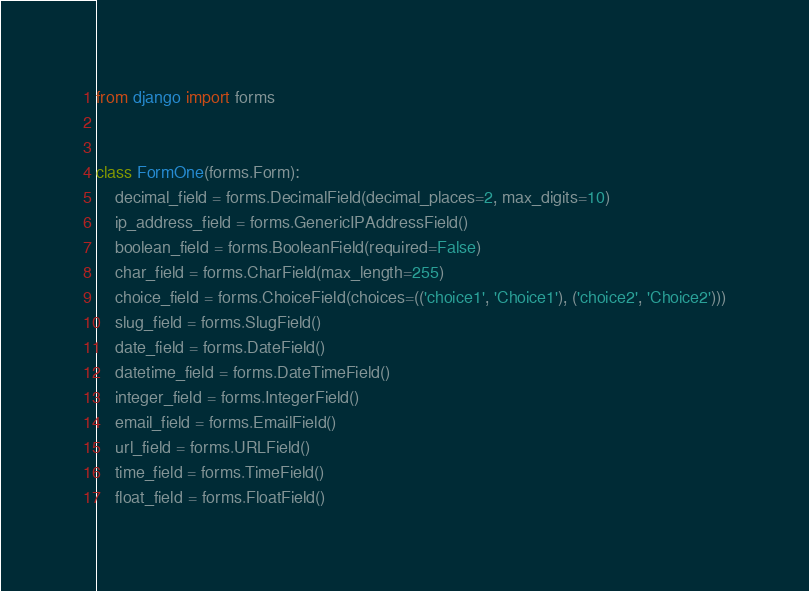<code> <loc_0><loc_0><loc_500><loc_500><_Python_>from django import forms


class FormOne(forms.Form):
    decimal_field = forms.DecimalField(decimal_places=2, max_digits=10)
    ip_address_field = forms.GenericIPAddressField()
    boolean_field = forms.BooleanField(required=False)
    char_field = forms.CharField(max_length=255)
    choice_field = forms.ChoiceField(choices=(('choice1', 'Choice1'), ('choice2', 'Choice2')))
    slug_field = forms.SlugField()
    date_field = forms.DateField()
    datetime_field = forms.DateTimeField()
    integer_field = forms.IntegerField()
    email_field = forms.EmailField()
    url_field = forms.URLField()
    time_field = forms.TimeField()
    float_field = forms.FloatField()
</code> 